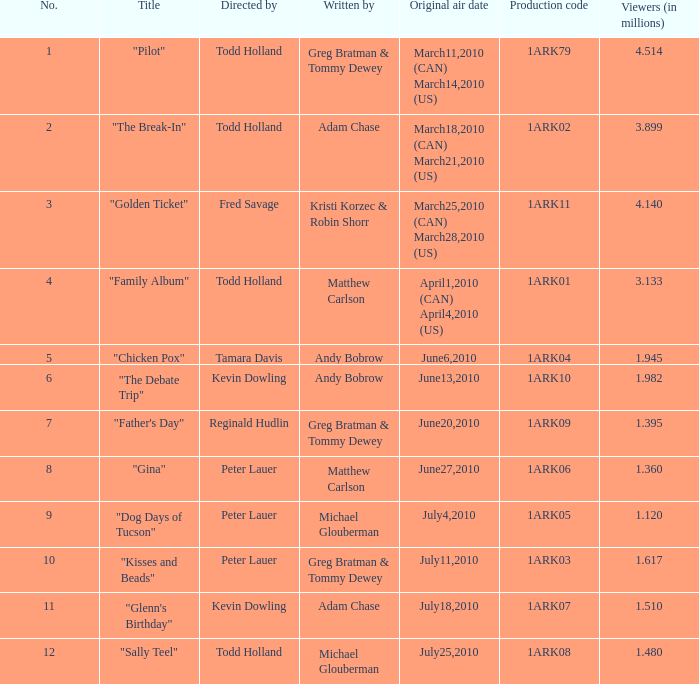What is the original air date for production code 1ark79? March11,2010 (CAN) March14,2010 (US). 